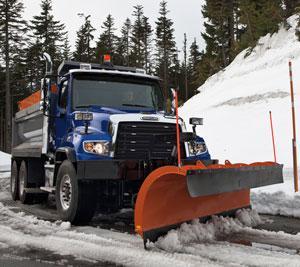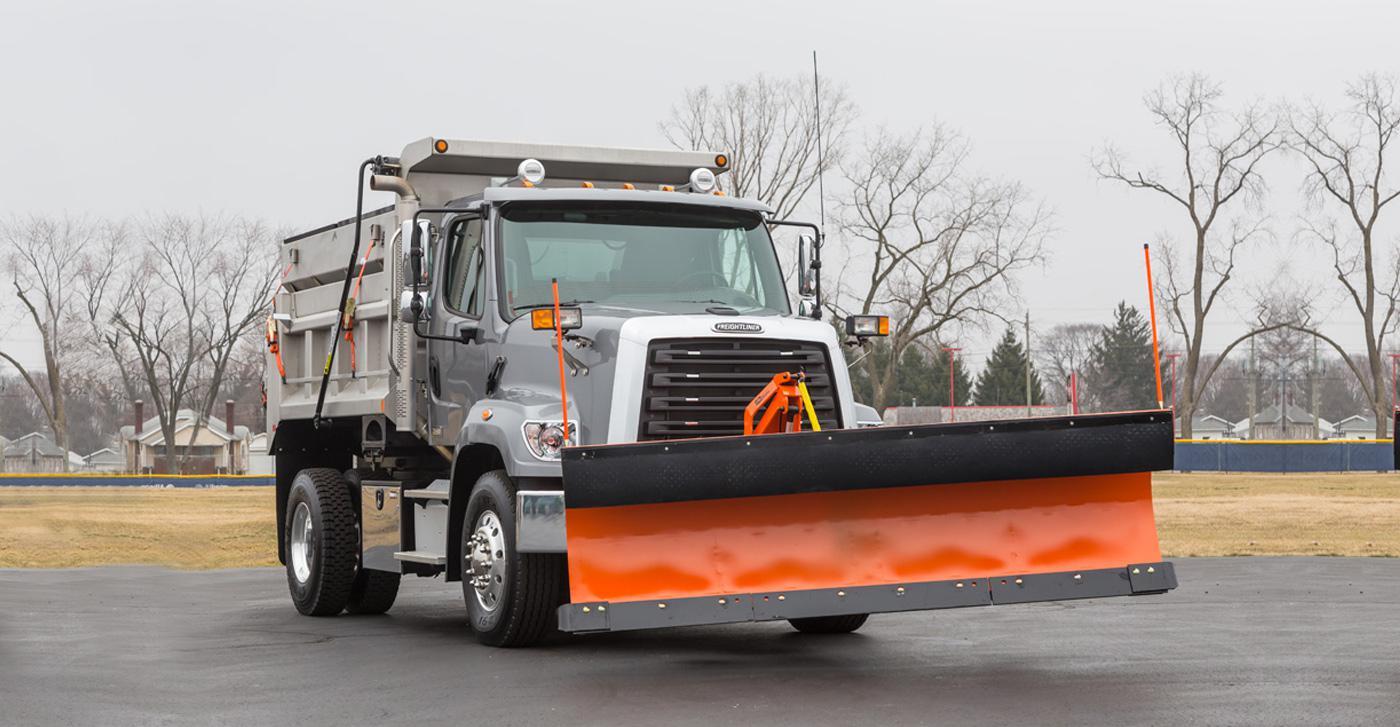The first image is the image on the left, the second image is the image on the right. Given the left and right images, does the statement "There is at least one blue truck in the images." hold true? Answer yes or no. Yes. 